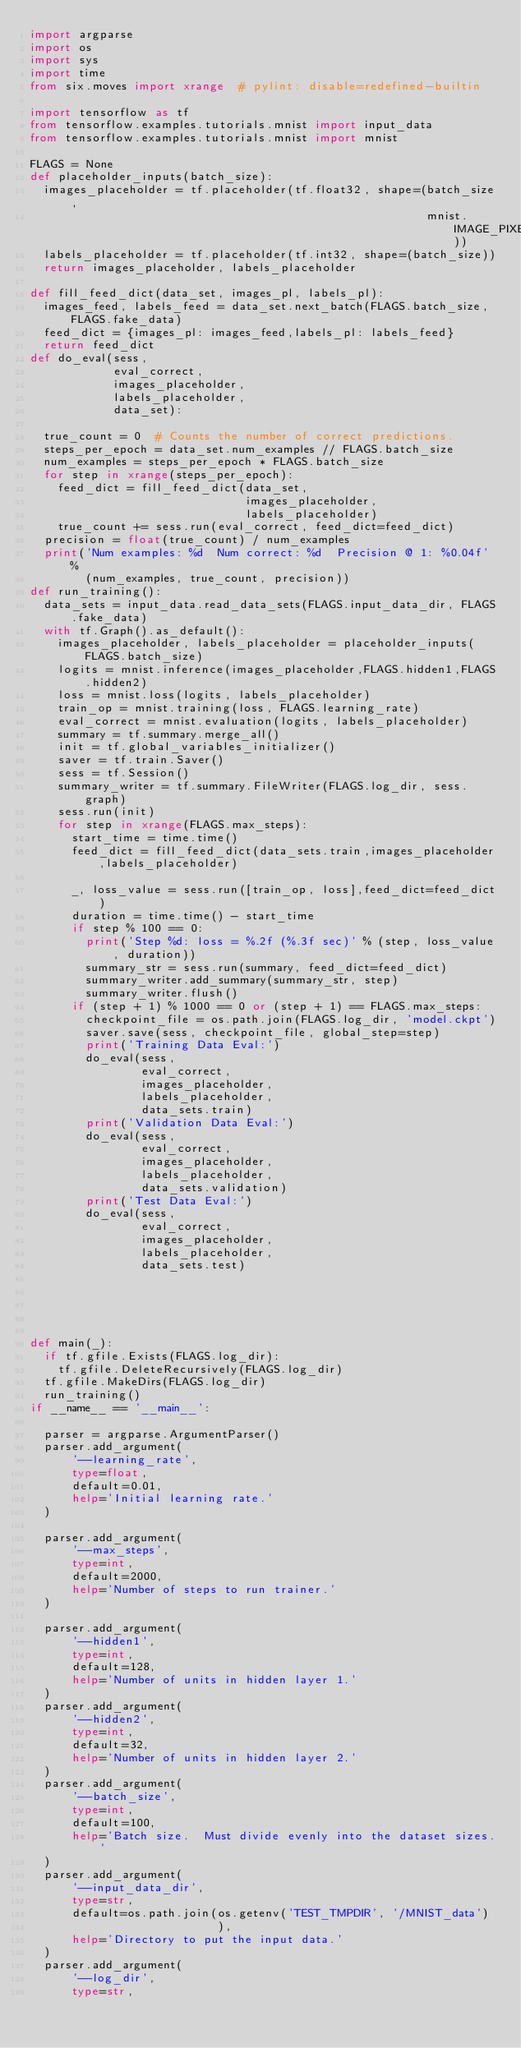Convert code to text. <code><loc_0><loc_0><loc_500><loc_500><_Python_>import argparse
import os
import sys
import time
from six.moves import xrange  # pylint: disable=redefined-builtin

import tensorflow as tf
from tensorflow.examples.tutorials.mnist import input_data
from tensorflow.examples.tutorials.mnist import mnist

FLAGS = None
def placeholder_inputs(batch_size):
  images_placeholder = tf.placeholder(tf.float32, shape=(batch_size,
                                                         mnist.IMAGE_PIXELS))
  labels_placeholder = tf.placeholder(tf.int32, shape=(batch_size))
  return images_placeholder, labels_placeholder

def fill_feed_dict(data_set, images_pl, labels_pl):
  images_feed, labels_feed = data_set.next_batch(FLAGS.batch_size,FLAGS.fake_data)
  feed_dict = {images_pl: images_feed,labels_pl: labels_feed}
  return feed_dict
def do_eval(sess,
            eval_correct,
            images_placeholder,
            labels_placeholder,
            data_set):

  true_count = 0  # Counts the number of correct predictions.
  steps_per_epoch = data_set.num_examples // FLAGS.batch_size
  num_examples = steps_per_epoch * FLAGS.batch_size
  for step in xrange(steps_per_epoch):
    feed_dict = fill_feed_dict(data_set,
                               images_placeholder,
                               labels_placeholder)
    true_count += sess.run(eval_correct, feed_dict=feed_dict)
  precision = float(true_count) / num_examples
  print('Num examples: %d  Num correct: %d  Precision @ 1: %0.04f' %
        (num_examples, true_count, precision))
def run_training():
  data_sets = input_data.read_data_sets(FLAGS.input_data_dir, FLAGS.fake_data)
  with tf.Graph().as_default():
    images_placeholder, labels_placeholder = placeholder_inputs(FLAGS.batch_size)
    logits = mnist.inference(images_placeholder,FLAGS.hidden1,FLAGS.hidden2)
    loss = mnist.loss(logits, labels_placeholder)
    train_op = mnist.training(loss, FLAGS.learning_rate)
    eval_correct = mnist.evaluation(logits, labels_placeholder)
    summary = tf.summary.merge_all()
    init = tf.global_variables_initializer()
    saver = tf.train.Saver()
    sess = tf.Session()
    summary_writer = tf.summary.FileWriter(FLAGS.log_dir, sess.graph)
    sess.run(init)
    for step in xrange(FLAGS.max_steps):
      start_time = time.time()
      feed_dict = fill_feed_dict(data_sets.train,images_placeholder,labels_placeholder)

      _, loss_value = sess.run([train_op, loss],feed_dict=feed_dict)
      duration = time.time() - start_time
      if step % 100 == 0:
        print('Step %d: loss = %.2f (%.3f sec)' % (step, loss_value, duration))
        summary_str = sess.run(summary, feed_dict=feed_dict)
        summary_writer.add_summary(summary_str, step)
        summary_writer.flush()
      if (step + 1) % 1000 == 0 or (step + 1) == FLAGS.max_steps:
        checkpoint_file = os.path.join(FLAGS.log_dir, 'model.ckpt')
        saver.save(sess, checkpoint_file, global_step=step)
        print('Training Data Eval:')
        do_eval(sess,
                eval_correct,
                images_placeholder,
                labels_placeholder,
                data_sets.train)
        print('Validation Data Eval:')
        do_eval(sess,
                eval_correct,
                images_placeholder,
                labels_placeholder,
                data_sets.validation)
        print('Test Data Eval:')
        do_eval(sess,
                eval_correct,
                images_placeholder,
                labels_placeholder,
                data_sets.test)





def main(_):
  if tf.gfile.Exists(FLAGS.log_dir):
    tf.gfile.DeleteRecursively(FLAGS.log_dir)
  tf.gfile.MakeDirs(FLAGS.log_dir)
  run_training()
if __name__ == '__main__':

  parser = argparse.ArgumentParser()
  parser.add_argument(
      '--learning_rate',
      type=float,
      default=0.01,
      help='Initial learning rate.'
  )

  parser.add_argument(
      '--max_steps',
      type=int,
      default=2000,
      help='Number of steps to run trainer.'
  )

  parser.add_argument(
      '--hidden1',
      type=int,
      default=128,
      help='Number of units in hidden layer 1.'
  )
  parser.add_argument(
      '--hidden2',
      type=int,
      default=32,
      help='Number of units in hidden layer 2.'
  )
  parser.add_argument(
      '--batch_size',
      type=int,
      default=100,
      help='Batch size.  Must divide evenly into the dataset sizes.'
  )
  parser.add_argument(
      '--input_data_dir',
      type=str,
      default=os.path.join(os.getenv('TEST_TMPDIR', '/MNIST_data')
                           ),
      help='Directory to put the input data.'
  )
  parser.add_argument(
      '--log_dir',
      type=str,</code> 